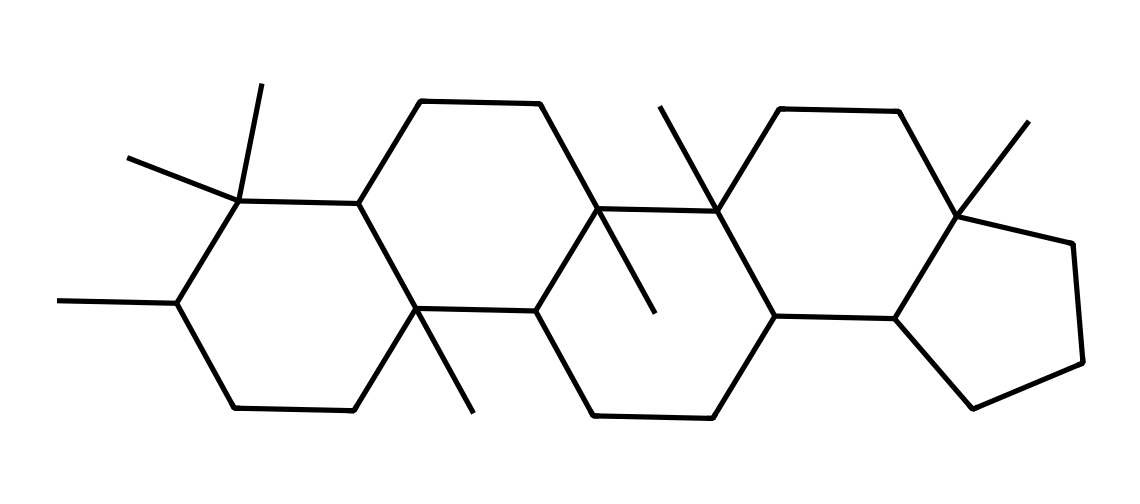What is the molecular formula of this lipid? To determine the molecular formula, count the unique carbon (C) and hydrogen (H) atoms in the structure. The SMILES representation suggests a complex cyclic structure with many branching alkyl groups. In total, there are 30 carbon atoms and 50 hydrogen atoms implied, summarized as C30H50.
Answer: C30H50 How many rings are present in this lipid's structure? Analyze the structure derived from the SMILES code to identify cyclic components. The structure reveals three distinct rings interlinked by various hydrocarbon chains, making a total of three rings.
Answer: 3 Is this lipid saturated or unsaturated? Look at the chemical structure to check for double bonds. In the provided SMILES, the absence of any double bonds indicates that it is composed solely of single bonds, which classifies it as saturated.
Answer: saturated What kind of lipid does this represent? This structure exemplifies a sterol or a steroid, found typically in biological membranes, characterized by its multi-ring structure. Its configuration aligns with sterolic entities, known for their roles in providing structural integrity in cell membranes.
Answer: steroid How many chiral centers are in this lipid? Examine the carbon atoms in the structure to identify chiral centers, which are typically carbon atoms bonded to four distinct groups. The analysis reveals that there are four such distinct carbon atoms, qualifying as chiral centers.
Answer: 4 What role do lipids like this play in ancient plant life? This lipid acts as a biomarker, indicating past vegetation as its presence in sedimentary rocks suggests the historical deposition of organic material from ancient plants, allowing for the reconstruction of past environments.
Answer: biomarker 